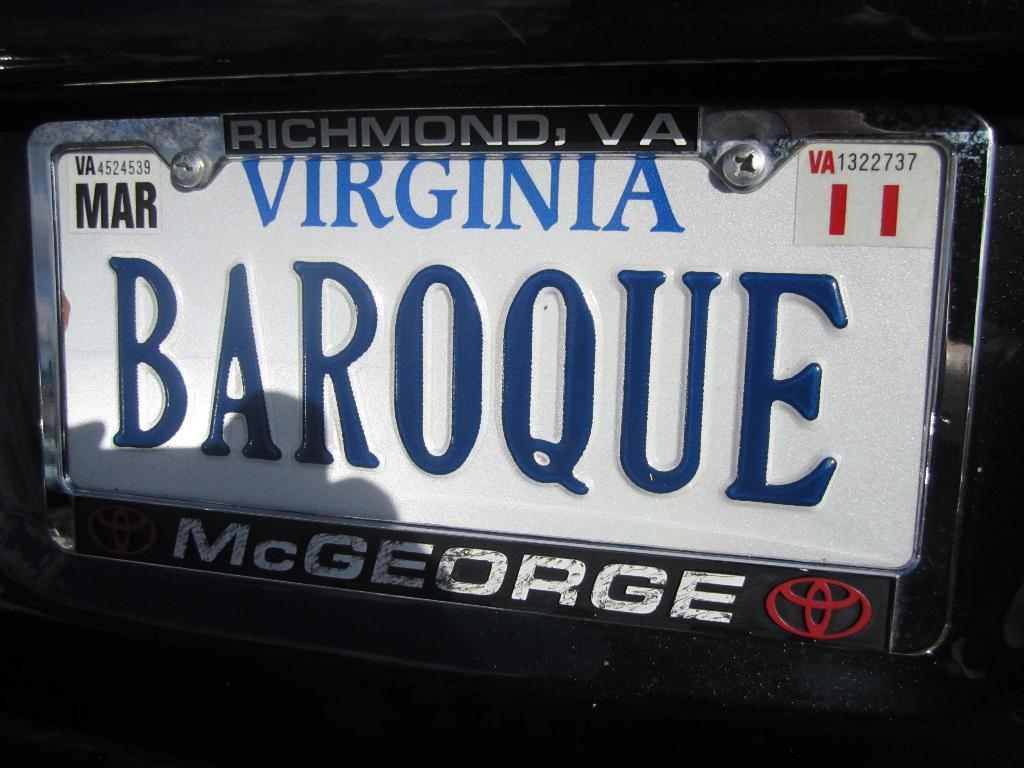<image>
Write a terse but informative summary of the picture. A plate from Virginia with the name McGeorge at the bottom. 